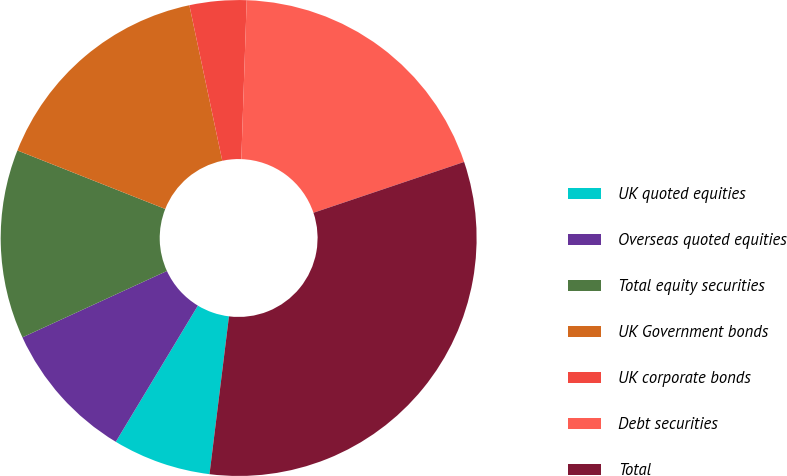Convert chart to OTSL. <chart><loc_0><loc_0><loc_500><loc_500><pie_chart><fcel>UK quoted equities<fcel>Overseas quoted equities<fcel>Total equity securities<fcel>UK Government bonds<fcel>UK corporate bonds<fcel>Debt securities<fcel>Total<nl><fcel>6.68%<fcel>9.51%<fcel>12.85%<fcel>15.68%<fcel>3.86%<fcel>19.28%<fcel>32.13%<nl></chart> 